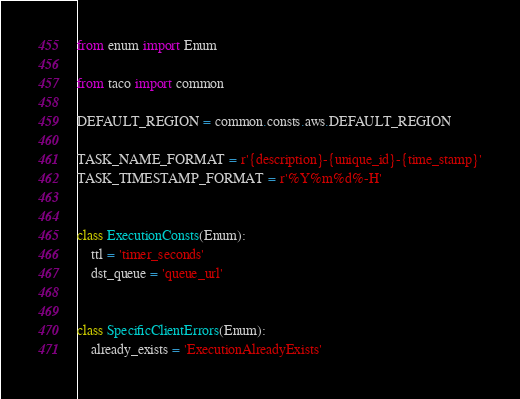Convert code to text. <code><loc_0><loc_0><loc_500><loc_500><_Python_>from enum import Enum

from taco import common

DEFAULT_REGION = common.consts.aws.DEFAULT_REGION

TASK_NAME_FORMAT = r'{description}-{unique_id}-{time_stamp}'
TASK_TIMESTAMP_FORMAT = r'%Y%m%d%-H'


class ExecutionConsts(Enum):
    ttl = 'timer_seconds'
    dst_queue = 'queue_url'


class SpecificClientErrors(Enum):
    already_exists = 'ExecutionAlreadyExists'
</code> 